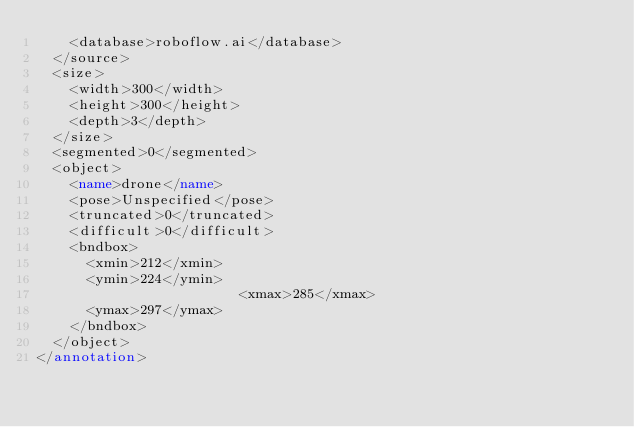Convert code to text. <code><loc_0><loc_0><loc_500><loc_500><_XML_>		<database>roboflow.ai</database>
	</source>
	<size>
		<width>300</width>
		<height>300</height>
		<depth>3</depth>
	</size>
	<segmented>0</segmented>
	<object>
		<name>drone</name>
		<pose>Unspecified</pose>
		<truncated>0</truncated>
		<difficult>0</difficult>
		<bndbox>
			<xmin>212</xmin>
			<ymin>224</ymin>
                        <xmax>285</xmax>
			<ymax>297</ymax>
		</bndbox>
	</object>
</annotation>
</code> 